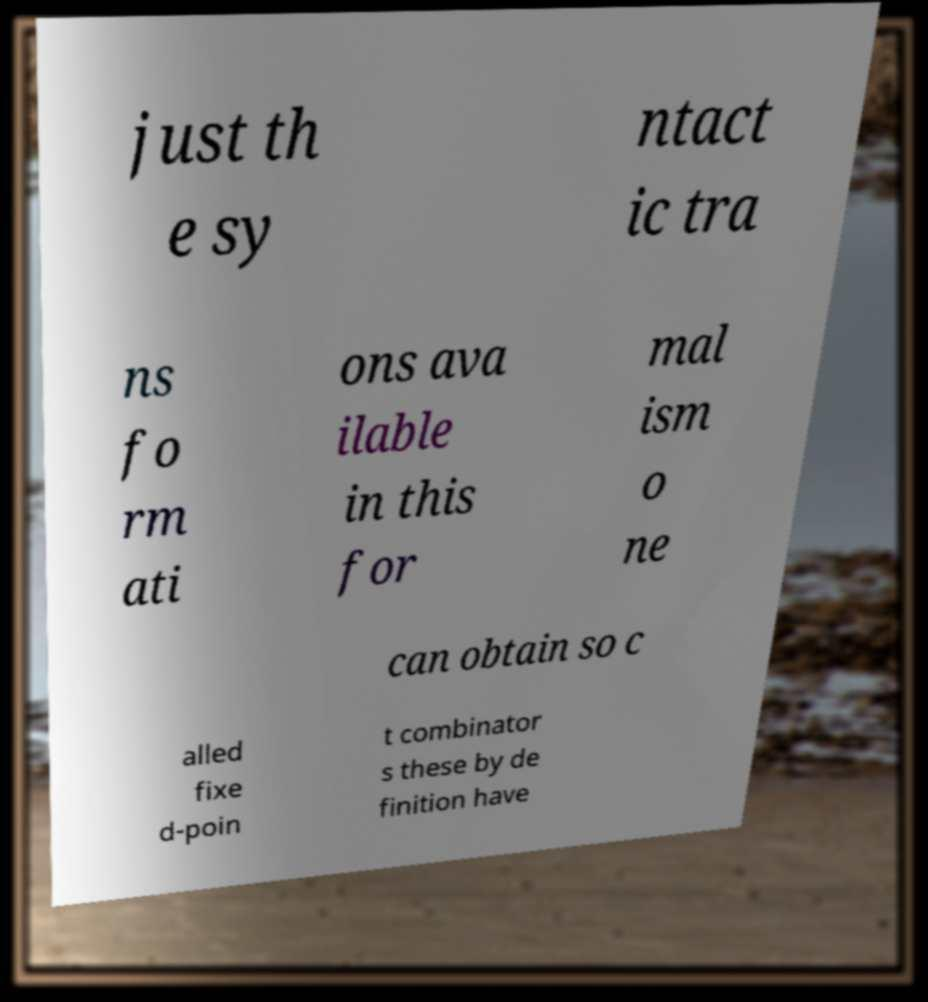Please identify and transcribe the text found in this image. just th e sy ntact ic tra ns fo rm ati ons ava ilable in this for mal ism o ne can obtain so c alled fixe d-poin t combinator s these by de finition have 